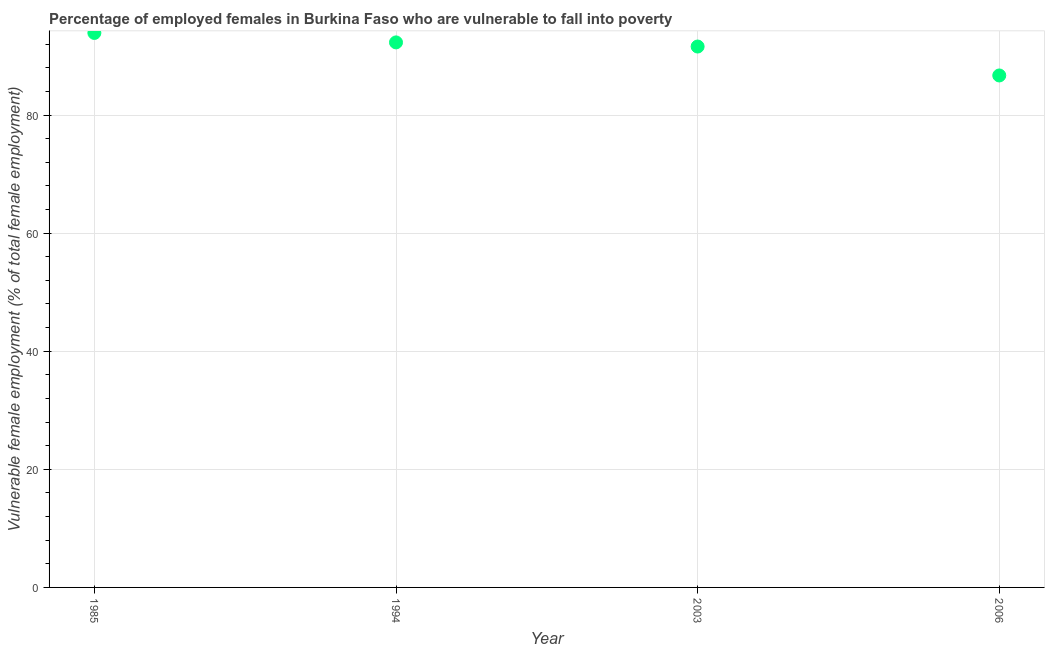What is the percentage of employed females who are vulnerable to fall into poverty in 1985?
Make the answer very short. 93.9. Across all years, what is the maximum percentage of employed females who are vulnerable to fall into poverty?
Your response must be concise. 93.9. Across all years, what is the minimum percentage of employed females who are vulnerable to fall into poverty?
Your answer should be very brief. 86.7. In which year was the percentage of employed females who are vulnerable to fall into poverty maximum?
Provide a short and direct response. 1985. What is the sum of the percentage of employed females who are vulnerable to fall into poverty?
Provide a short and direct response. 364.5. What is the difference between the percentage of employed females who are vulnerable to fall into poverty in 1994 and 2003?
Make the answer very short. 0.7. What is the average percentage of employed females who are vulnerable to fall into poverty per year?
Provide a succinct answer. 91.12. What is the median percentage of employed females who are vulnerable to fall into poverty?
Ensure brevity in your answer.  91.95. In how many years, is the percentage of employed females who are vulnerable to fall into poverty greater than 36 %?
Offer a terse response. 4. What is the ratio of the percentage of employed females who are vulnerable to fall into poverty in 1994 to that in 2006?
Keep it short and to the point. 1.06. Is the percentage of employed females who are vulnerable to fall into poverty in 1985 less than that in 2003?
Give a very brief answer. No. Is the difference between the percentage of employed females who are vulnerable to fall into poverty in 1985 and 1994 greater than the difference between any two years?
Your answer should be compact. No. What is the difference between the highest and the second highest percentage of employed females who are vulnerable to fall into poverty?
Keep it short and to the point. 1.6. Is the sum of the percentage of employed females who are vulnerable to fall into poverty in 1994 and 2006 greater than the maximum percentage of employed females who are vulnerable to fall into poverty across all years?
Give a very brief answer. Yes. What is the difference between the highest and the lowest percentage of employed females who are vulnerable to fall into poverty?
Your answer should be compact. 7.2. What is the difference between two consecutive major ticks on the Y-axis?
Your response must be concise. 20. Does the graph contain grids?
Your answer should be very brief. Yes. What is the title of the graph?
Make the answer very short. Percentage of employed females in Burkina Faso who are vulnerable to fall into poverty. What is the label or title of the Y-axis?
Ensure brevity in your answer.  Vulnerable female employment (% of total female employment). What is the Vulnerable female employment (% of total female employment) in 1985?
Give a very brief answer. 93.9. What is the Vulnerable female employment (% of total female employment) in 1994?
Your answer should be very brief. 92.3. What is the Vulnerable female employment (% of total female employment) in 2003?
Your answer should be compact. 91.6. What is the Vulnerable female employment (% of total female employment) in 2006?
Keep it short and to the point. 86.7. What is the difference between the Vulnerable female employment (% of total female employment) in 1985 and 1994?
Offer a very short reply. 1.6. What is the difference between the Vulnerable female employment (% of total female employment) in 1985 and 2006?
Offer a terse response. 7.2. What is the difference between the Vulnerable female employment (% of total female employment) in 1994 and 2003?
Ensure brevity in your answer.  0.7. What is the difference between the Vulnerable female employment (% of total female employment) in 1994 and 2006?
Your response must be concise. 5.6. What is the ratio of the Vulnerable female employment (% of total female employment) in 1985 to that in 1994?
Provide a short and direct response. 1.02. What is the ratio of the Vulnerable female employment (% of total female employment) in 1985 to that in 2006?
Your response must be concise. 1.08. What is the ratio of the Vulnerable female employment (% of total female employment) in 1994 to that in 2003?
Make the answer very short. 1.01. What is the ratio of the Vulnerable female employment (% of total female employment) in 1994 to that in 2006?
Give a very brief answer. 1.06. What is the ratio of the Vulnerable female employment (% of total female employment) in 2003 to that in 2006?
Ensure brevity in your answer.  1.06. 